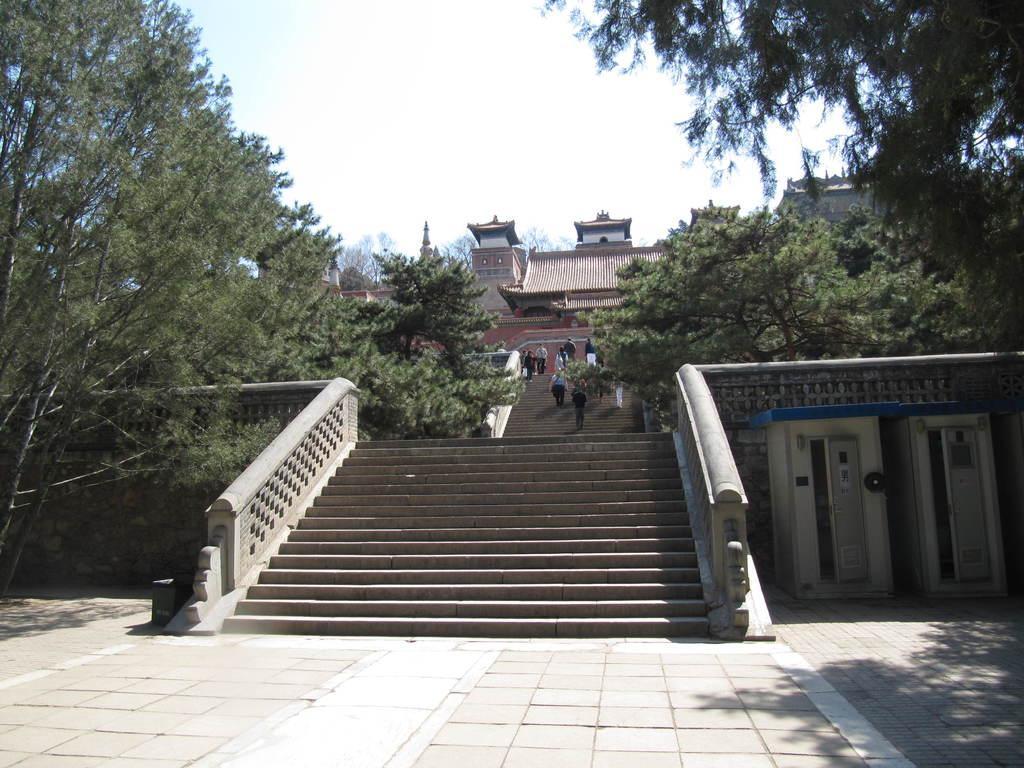Can you describe this image briefly? In the center of the image there are stairs and we can see people climbing the stairs. There are trees. In the background there are buildings and sky. 